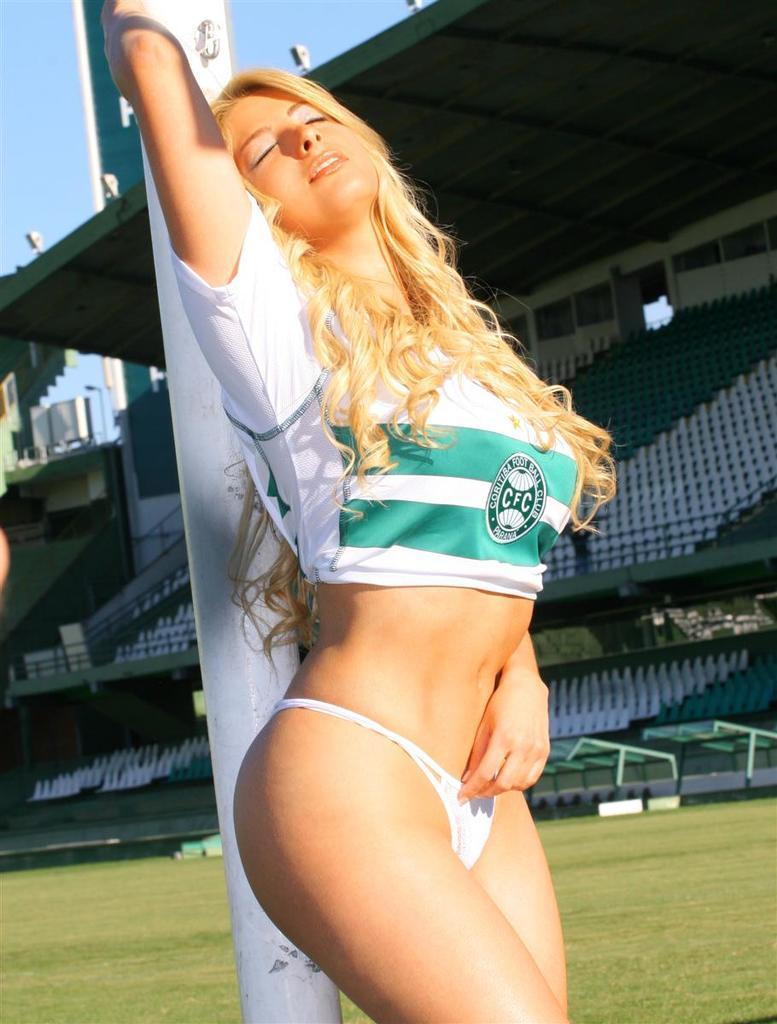How would you summarize this image in a sentence or two? In the center of the image we can see a pole and a lady is standing and wearing a dress. In the background of the image we can see the ground, stairs, rods, boards. At the top of the image we can see the sky and lights. 